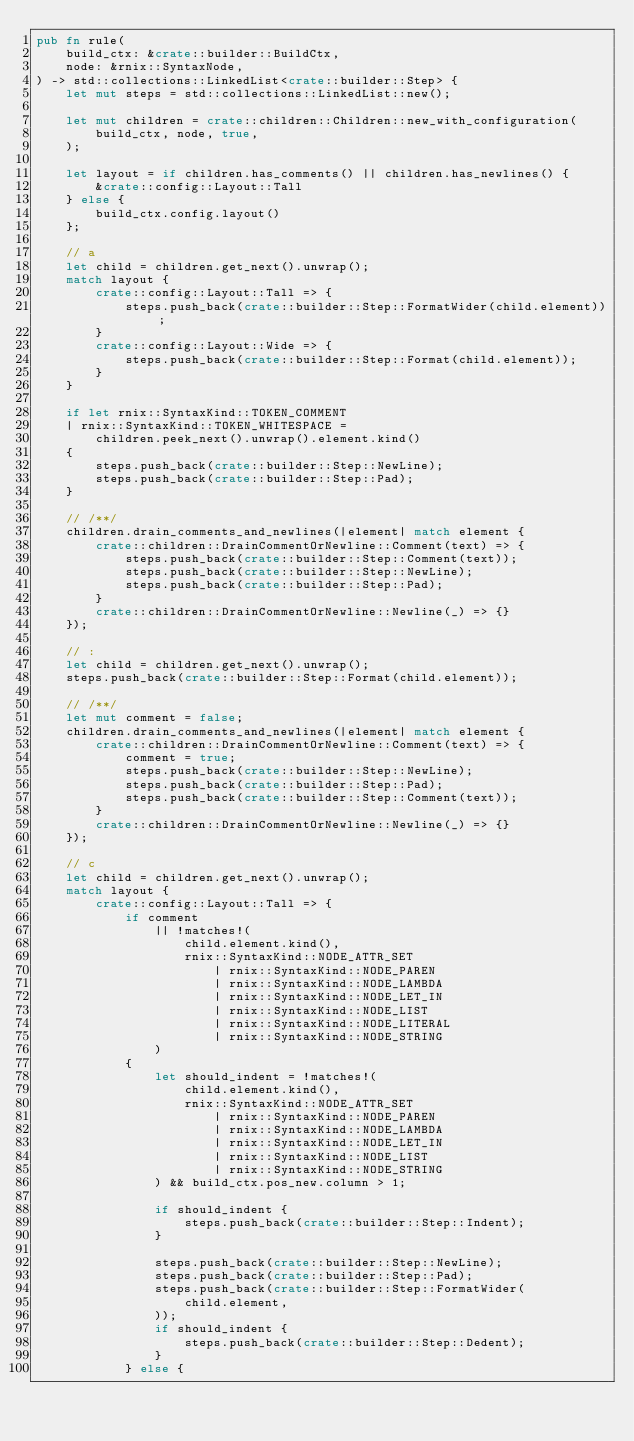Convert code to text. <code><loc_0><loc_0><loc_500><loc_500><_Rust_>pub fn rule(
    build_ctx: &crate::builder::BuildCtx,
    node: &rnix::SyntaxNode,
) -> std::collections::LinkedList<crate::builder::Step> {
    let mut steps = std::collections::LinkedList::new();

    let mut children = crate::children::Children::new_with_configuration(
        build_ctx, node, true,
    );

    let layout = if children.has_comments() || children.has_newlines() {
        &crate::config::Layout::Tall
    } else {
        build_ctx.config.layout()
    };

    // a
    let child = children.get_next().unwrap();
    match layout {
        crate::config::Layout::Tall => {
            steps.push_back(crate::builder::Step::FormatWider(child.element));
        }
        crate::config::Layout::Wide => {
            steps.push_back(crate::builder::Step::Format(child.element));
        }
    }

    if let rnix::SyntaxKind::TOKEN_COMMENT
    | rnix::SyntaxKind::TOKEN_WHITESPACE =
        children.peek_next().unwrap().element.kind()
    {
        steps.push_back(crate::builder::Step::NewLine);
        steps.push_back(crate::builder::Step::Pad);
    }

    // /**/
    children.drain_comments_and_newlines(|element| match element {
        crate::children::DrainCommentOrNewline::Comment(text) => {
            steps.push_back(crate::builder::Step::Comment(text));
            steps.push_back(crate::builder::Step::NewLine);
            steps.push_back(crate::builder::Step::Pad);
        }
        crate::children::DrainCommentOrNewline::Newline(_) => {}
    });

    // :
    let child = children.get_next().unwrap();
    steps.push_back(crate::builder::Step::Format(child.element));

    // /**/
    let mut comment = false;
    children.drain_comments_and_newlines(|element| match element {
        crate::children::DrainCommentOrNewline::Comment(text) => {
            comment = true;
            steps.push_back(crate::builder::Step::NewLine);
            steps.push_back(crate::builder::Step::Pad);
            steps.push_back(crate::builder::Step::Comment(text));
        }
        crate::children::DrainCommentOrNewline::Newline(_) => {}
    });

    // c
    let child = children.get_next().unwrap();
    match layout {
        crate::config::Layout::Tall => {
            if comment
                || !matches!(
                    child.element.kind(),
                    rnix::SyntaxKind::NODE_ATTR_SET
                        | rnix::SyntaxKind::NODE_PAREN
                        | rnix::SyntaxKind::NODE_LAMBDA
                        | rnix::SyntaxKind::NODE_LET_IN
                        | rnix::SyntaxKind::NODE_LIST
                        | rnix::SyntaxKind::NODE_LITERAL
                        | rnix::SyntaxKind::NODE_STRING
                )
            {
                let should_indent = !matches!(
                    child.element.kind(),
                    rnix::SyntaxKind::NODE_ATTR_SET
                        | rnix::SyntaxKind::NODE_PAREN
                        | rnix::SyntaxKind::NODE_LAMBDA
                        | rnix::SyntaxKind::NODE_LET_IN
                        | rnix::SyntaxKind::NODE_LIST
                        | rnix::SyntaxKind::NODE_STRING
                ) && build_ctx.pos_new.column > 1;

                if should_indent {
                    steps.push_back(crate::builder::Step::Indent);
                }

                steps.push_back(crate::builder::Step::NewLine);
                steps.push_back(crate::builder::Step::Pad);
                steps.push_back(crate::builder::Step::FormatWider(
                    child.element,
                ));
                if should_indent {
                    steps.push_back(crate::builder::Step::Dedent);
                }
            } else {</code> 